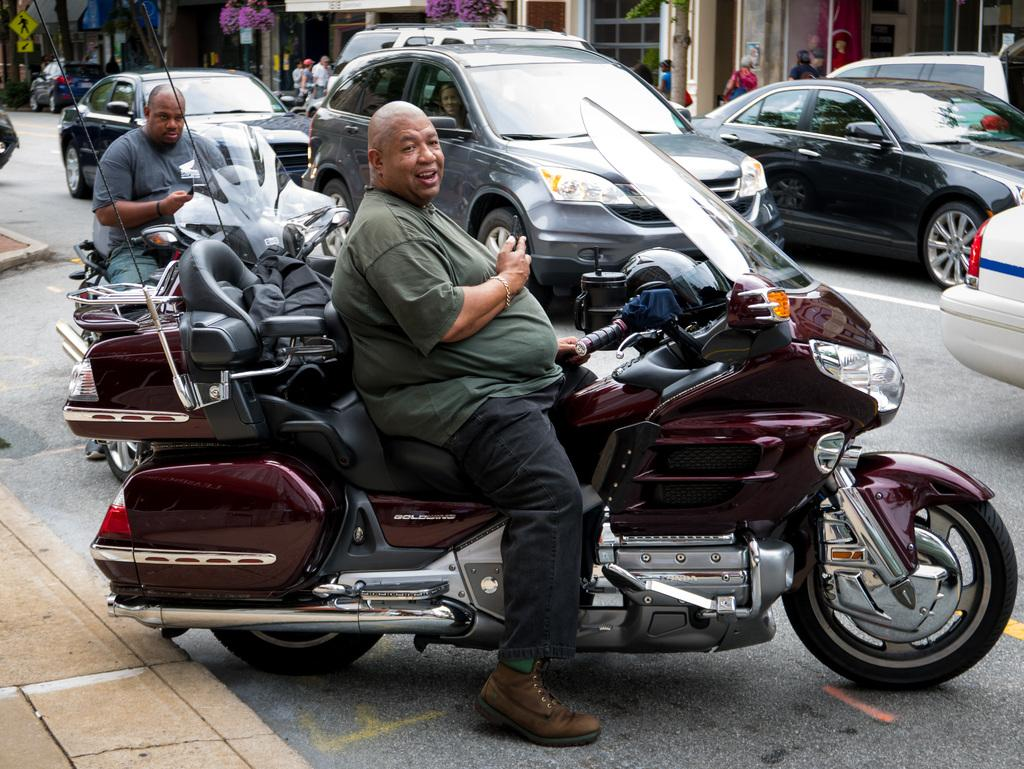Who is present in the image? There are old men in the image. What are the old men doing in the image? The old men are sitting on motorbikes. What can be seen behind the motorbikes in the image? There are cars visible behind the motorbikes. What type of canvas is being used by the women in the image? There are no women or canvas present in the image; it features old men sitting on motorbikes with cars visible behind them. 